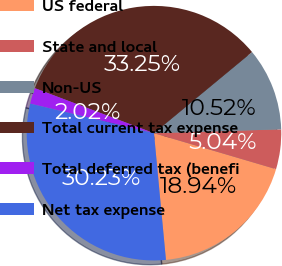Convert chart. <chart><loc_0><loc_0><loc_500><loc_500><pie_chart><fcel>US federal<fcel>State and local<fcel>Non-US<fcel>Total current tax expense<fcel>Total deferred tax (benefi<fcel>Net tax expense<nl><fcel>18.94%<fcel>5.04%<fcel>10.52%<fcel>33.25%<fcel>2.02%<fcel>30.23%<nl></chart> 